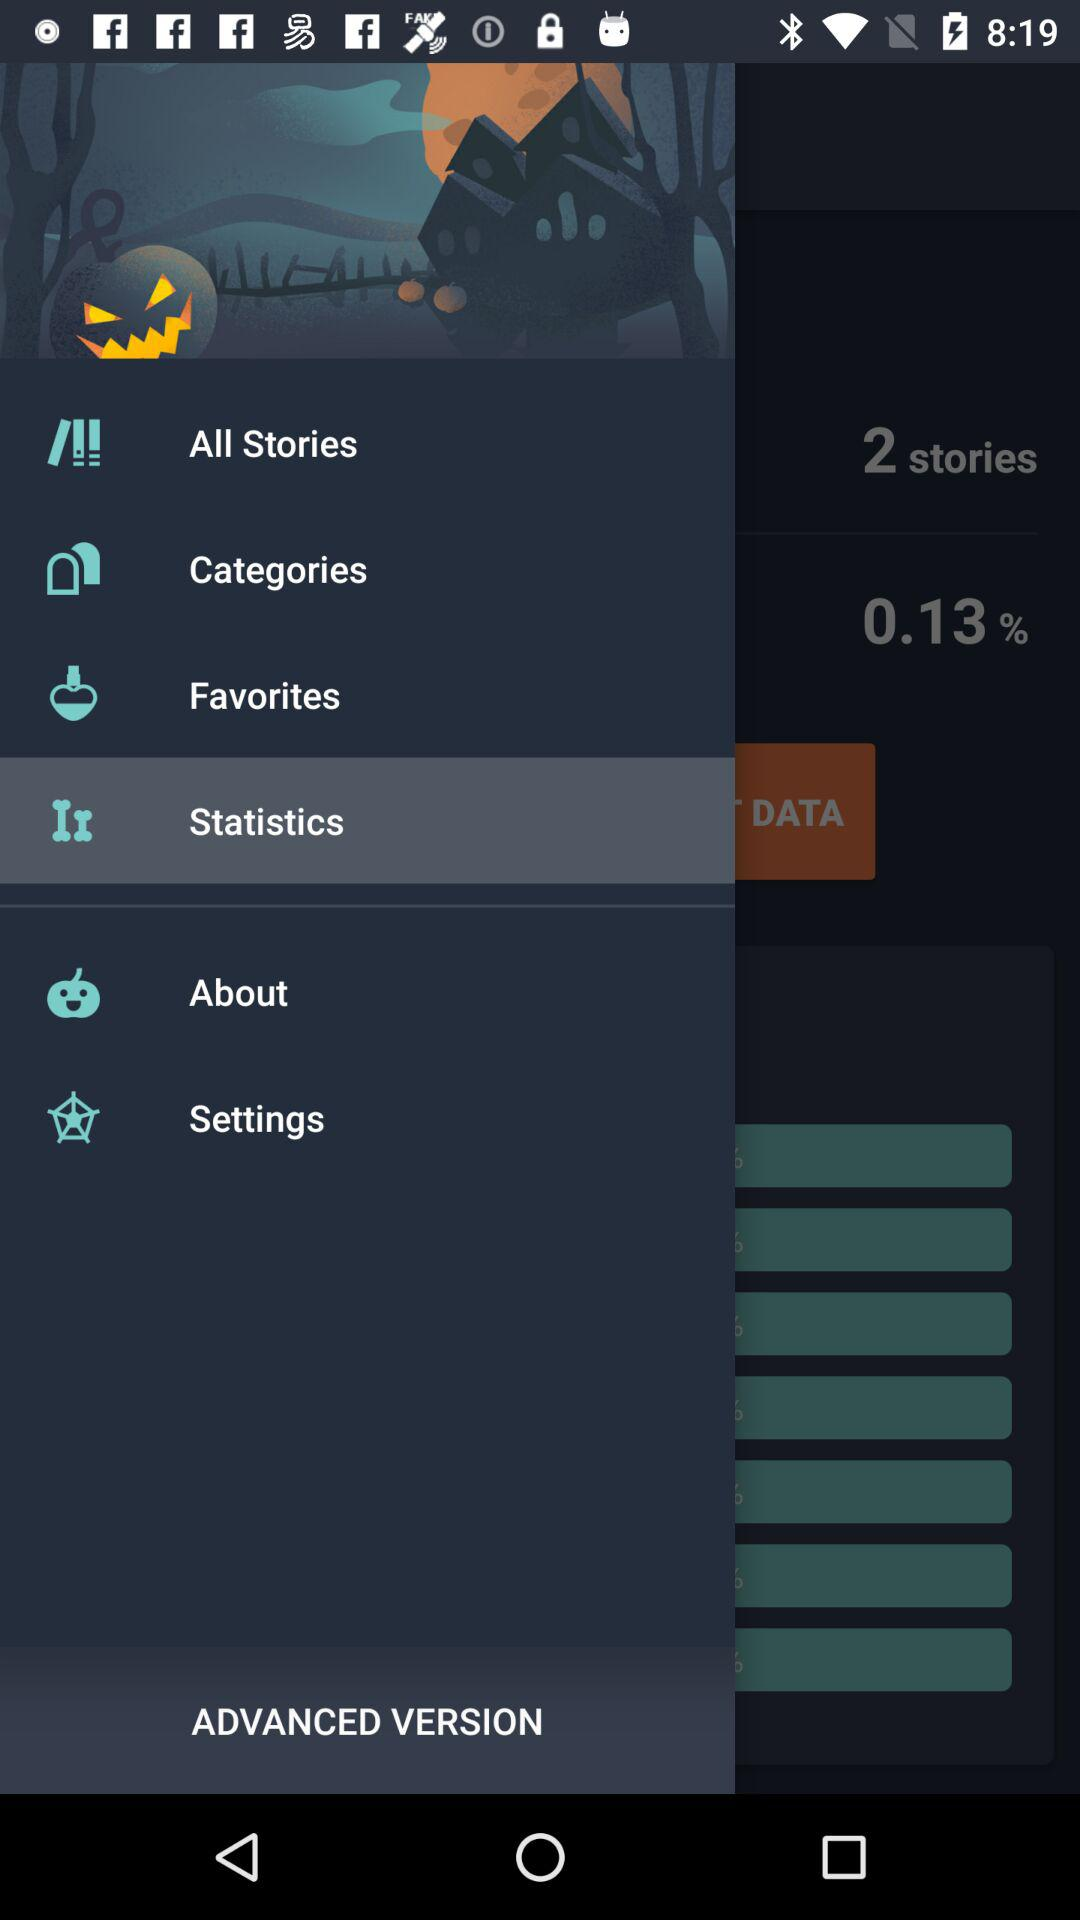Which is the selected item in the menu? The selected item is "Statistics". 